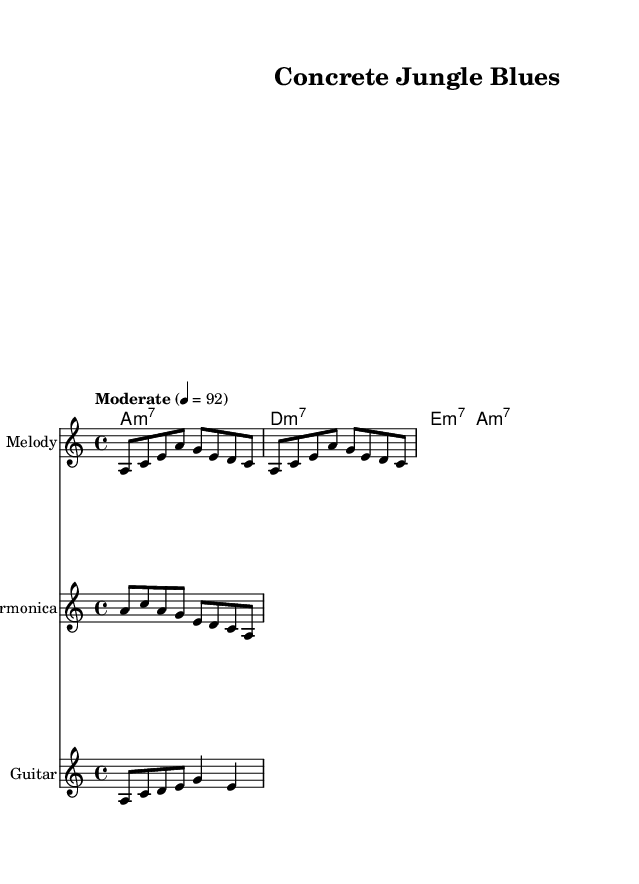What is the key signature of this music? The key signature indicates that this piece is in A minor, as there is one sharp noted in the key signature placement.
Answer: A minor What is the time signature of this music? The time signature is indicated near the beginning of the score, and it shows a 4/4 pattern, meaning there are four beats in each measure.
Answer: 4/4 What is the tempo marking for this music? The tempo markings can be found near the top of the score, stating "Moderate" with a metronome mark of 92, indicating a moderate pace for the piece.
Answer: Moderate 4 = 92 How many measures are in the melody section? By counting the measures represented in the melody staff, there are a total of two full measures provided in the notation.
Answer: 2 measures What emotional theme is suggested by the lyrics of the song? Analyzing the provided lyrics, words like "Concrete jungle" and "always alone" suggest a theme of loneliness and struggle in an urban environment, characteristic of the blues genre.
Answer: Loneliness What type of chords are used in the harmonies section? The chord section labeled as "harmonies" indicates that the chords are all minor seventh chords, which is a common trait in blues music that adds to its emotional depth.
Answer: Minor seventh chords Which instruments are featured in this score? The score lists three distinct instruments: Melody, Harmonica, and Guitar, each showcased on its own staff for clarity.
Answer: Melody, Harmonica, Guitar 